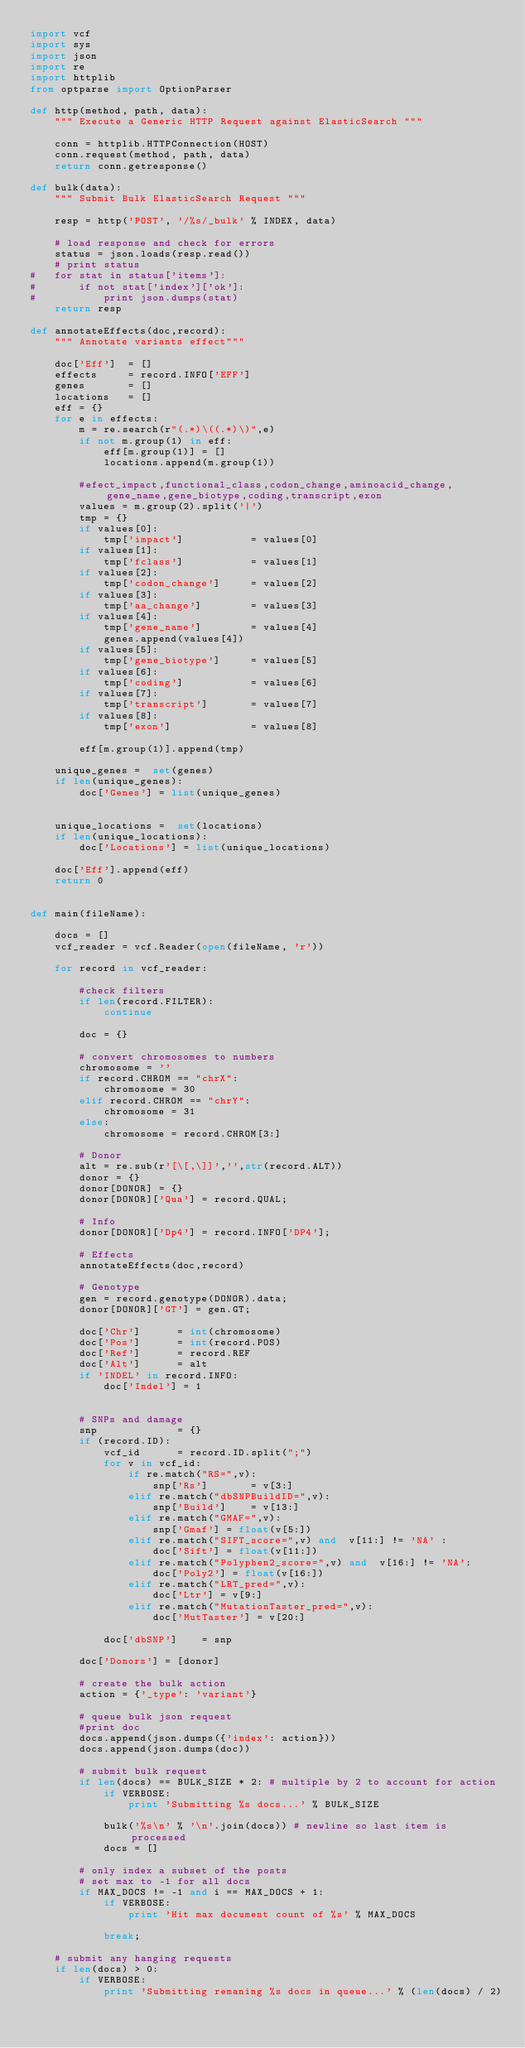<code> <loc_0><loc_0><loc_500><loc_500><_Python_>import vcf
import sys
import json
import re
import httplib
from optparse import OptionParser

def http(method, path, data):
    """ Execute a Generic HTTP Request against ElasticSearch """
 
    conn = httplib.HTTPConnection(HOST)
    conn.request(method, path, data)
    return conn.getresponse()
    
def bulk(data):
	""" Submit Bulk ElasticSearch Request """
	
	resp = http('POST', '/%s/_bulk' % INDEX, data)
	
	# load response and check for errors
	status = json.loads(resp.read())
	# print status 
# 	for stat in status['items']:
# 		if not stat['index']['ok']:
# 			print json.dumps(stat)
	return resp
	
def annotateEffects(doc,record):
	""" Annotate variants effect"""	
	
	doc['Eff'] 	= []
	effects 	= record.INFO['EFF']
	genes 		= []
	locations 	= []
	eff = {}
	for e in effects:
		m = re.search(r"(.*)\((.*)\)",e)
		if not m.group(1) in eff:
			eff[m.group(1)] = []
			locations.append(m.group(1))
	
		#efect_impact,functional_class,codon_change,aminoacid_change,gene_name,gene_biotype,coding,transcript,exon
		values = m.group(2).split('|')
		tmp = {}
		if values[0]:
			tmp['impact'] 			= values[0]
		if values[1]:
			tmp['fclass'] 			= values[1]
		if values[2]:
			tmp['codon_change'] 	= values[2]
		if values[3]:
			tmp['aa_change'] 		= values[3]
		if values[4]:
			tmp['gene_name'] 		= values[4]
			genes.append(values[4])
		if values[5]:
			tmp['gene_biotype'] 	= values[5]
		if values[6]:
			tmp['coding'] 			= values[6]
		if values[7]:
			tmp['transcript'] 		= values[7]
		if values[8]:
			tmp['exon'] 			= values[8]
		
		eff[m.group(1)].append(tmp)
		
	unique_genes =  set(genes)
	if len(unique_genes):
		doc['Genes'] = list(unique_genes)	
		
		
	unique_locations =  set(locations)
	if len(unique_locations):
		doc['Locations'] = list(unique_locations)			
				
	doc['Eff'].append(eff)
	return 0


def main(fileName):

	docs = []
	vcf_reader = vcf.Reader(open(fileName, 'r'))
	
	for record in vcf_reader:
	
		#check filters
		if len(record.FILTER):
			continue
	
		doc = {}
		
		# convert chromosomes to numbers
		chromosome = ''
		if record.CHROM == "chrX":
			chromosome = 30
		elif record.CHROM == "chrY":
			chromosome = 31
		else:
			chromosome = record.CHROM[3:]	

		# Donor
		alt = re.sub(r'[\[,\]]','',str(record.ALT))	
		donor = {}
		donor[DONOR] = {}
		donor[DONOR]['Qua']	= record.QUAL;	
		
		# Info
		donor[DONOR]['Dp4'] = record.INFO['DP4'];
				
		# Effects
		annotateEffects(doc,record)
			
		# Genotype
		gen = record.genotype(DONOR).data;
		donor[DONOR]['GT'] = gen.GT;
		
		doc['Chr'] 		= int(chromosome)
		doc['Pos'] 		= int(record.POS)
		doc['Ref'] 		= record.REF
		doc['Alt'] 		= alt
		if 'INDEL' in record.INFO:
			doc['Indel'] = 1 
		
	
		# SNPs and damage 
		snp 			= {}
		if (record.ID):
			vcf_id 		= record.ID.split(";")
			for v in vcf_id:
				if re.match("RS=",v):
					snp['Rs']		= v[3:]
				elif re.match("dbSNPBuildID=",v):	
					snp['Build']	= v[13:] 
				elif re.match("GMAF=",v):
					snp['Gmaf']	= float(v[5:])	
				elif re.match("SIFT_score=",v) and  v[11:] != 'NA' :	
					doc['Sift'] = float(v[11:])
				elif re.match("Polyphen2_score=",v) and  v[16:] != 'NA':
					doc['Poly2'] = float(v[16:])	
				elif re.match("LRT_pred=",v):	
					doc['Ltr'] = v[9:]	
				elif re.match("MutationTaster_pred=",v):	
					doc['MutTaster'] = v[20:]		
			
			doc['dbSNP'] 	= snp

		doc['Donors'] = [donor]
		
		# create the bulk action
		action = {'_type': 'variant'}
		    
		# queue bulk json request
		#print doc	
		docs.append(json.dumps({'index': action}))
		docs.append(json.dumps(doc))
		
		# submit bulk request
		if len(docs) == BULK_SIZE * 2: # multiple by 2 to account for action
		    if VERBOSE:
		        print 'Submitting %s docs...' % BULK_SIZE
		        
 		    bulk('%s\n' % '\n'.join(docs)) # newline so last item is processed
		    docs = []
		    
		# only index a subset of the posts
		# set max to -1 for all docs
		if MAX_DOCS != -1 and i == MAX_DOCS + 1:
		    if VERBOSE:
		        print 'Hit max document count of %s' % MAX_DOCS
		        
		    break;
            
    # submit any hanging requests
	if len(docs) > 0:
	    if VERBOSE:
	        print 'Submitting remaning %s docs in queue...' % (len(docs) / 2)
	        </code> 